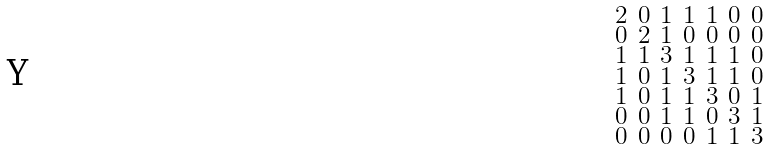<formula> <loc_0><loc_0><loc_500><loc_500>\begin{smallmatrix} 2 & 0 & 1 & 1 & 1 & 0 & 0 \\ 0 & 2 & 1 & 0 & 0 & 0 & 0 \\ 1 & 1 & 3 & 1 & 1 & 1 & 0 \\ 1 & 0 & 1 & 3 & 1 & 1 & 0 \\ 1 & 0 & 1 & 1 & 3 & 0 & 1 \\ 0 & 0 & 1 & 1 & 0 & 3 & 1 \\ 0 & 0 & 0 & 0 & 1 & 1 & 3 \end{smallmatrix}</formula> 